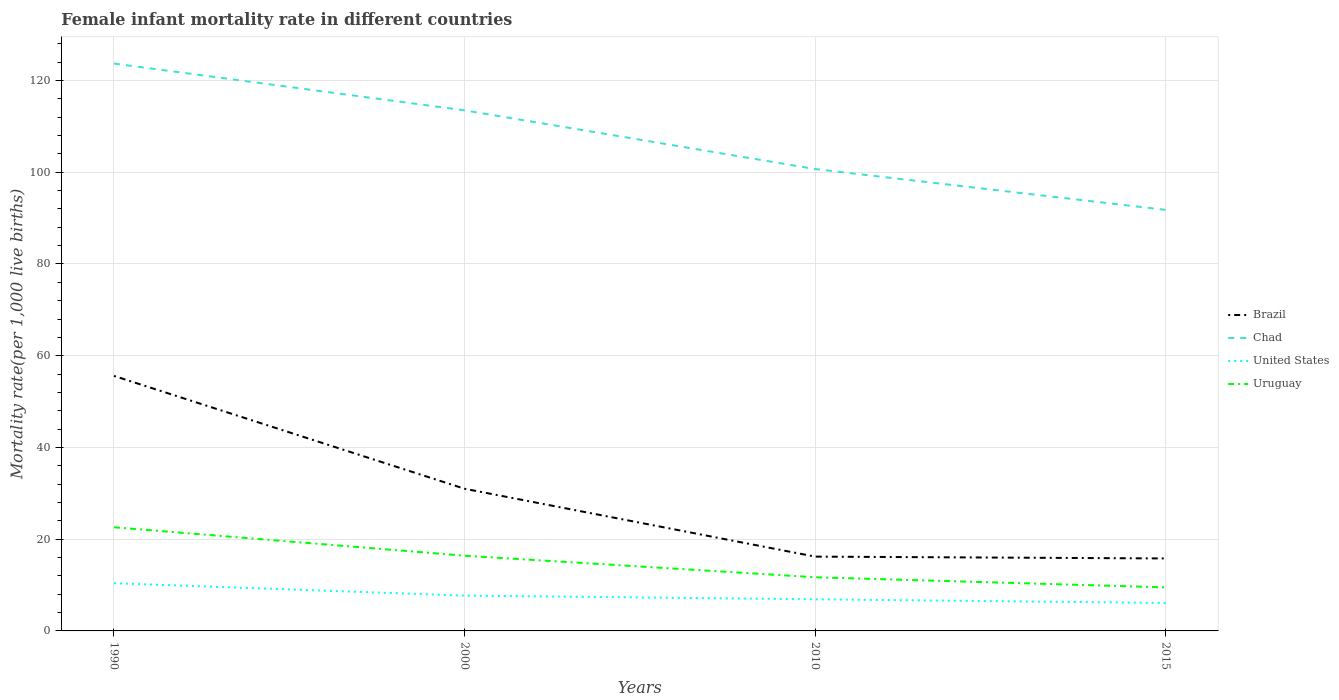In which year was the female infant mortality rate in Chad maximum?
Offer a very short reply. 2015. What is the total female infant mortality rate in Brazil in the graph?
Your response must be concise. 15.2. What is the difference between the highest and the second highest female infant mortality rate in United States?
Provide a short and direct response. 4.3. Is the female infant mortality rate in United States strictly greater than the female infant mortality rate in Uruguay over the years?
Ensure brevity in your answer.  Yes. How many years are there in the graph?
Make the answer very short. 4. What is the difference between two consecutive major ticks on the Y-axis?
Keep it short and to the point. 20. Does the graph contain grids?
Your answer should be very brief. Yes. Where does the legend appear in the graph?
Your response must be concise. Center right. How are the legend labels stacked?
Your response must be concise. Vertical. What is the title of the graph?
Your response must be concise. Female infant mortality rate in different countries. Does "Grenada" appear as one of the legend labels in the graph?
Give a very brief answer. No. What is the label or title of the Y-axis?
Your answer should be very brief. Mortality rate(per 1,0 live births). What is the Mortality rate(per 1,000 live births) of Brazil in 1990?
Your answer should be very brief. 55.6. What is the Mortality rate(per 1,000 live births) of Chad in 1990?
Offer a very short reply. 123.7. What is the Mortality rate(per 1,000 live births) of United States in 1990?
Make the answer very short. 10.4. What is the Mortality rate(per 1,000 live births) in Uruguay in 1990?
Provide a short and direct response. 22.6. What is the Mortality rate(per 1,000 live births) of Chad in 2000?
Your answer should be very brief. 113.5. What is the Mortality rate(per 1,000 live births) of Brazil in 2010?
Keep it short and to the point. 16.2. What is the Mortality rate(per 1,000 live births) of Chad in 2010?
Keep it short and to the point. 100.7. What is the Mortality rate(per 1,000 live births) of Uruguay in 2010?
Provide a succinct answer. 11.7. What is the Mortality rate(per 1,000 live births) of Chad in 2015?
Ensure brevity in your answer.  91.8. What is the Mortality rate(per 1,000 live births) in United States in 2015?
Your answer should be compact. 6.1. What is the Mortality rate(per 1,000 live births) in Uruguay in 2015?
Ensure brevity in your answer.  9.5. Across all years, what is the maximum Mortality rate(per 1,000 live births) of Brazil?
Provide a succinct answer. 55.6. Across all years, what is the maximum Mortality rate(per 1,000 live births) in Chad?
Keep it short and to the point. 123.7. Across all years, what is the maximum Mortality rate(per 1,000 live births) in Uruguay?
Make the answer very short. 22.6. Across all years, what is the minimum Mortality rate(per 1,000 live births) of Chad?
Offer a terse response. 91.8. What is the total Mortality rate(per 1,000 live births) in Brazil in the graph?
Your response must be concise. 118.6. What is the total Mortality rate(per 1,000 live births) in Chad in the graph?
Ensure brevity in your answer.  429.7. What is the total Mortality rate(per 1,000 live births) of United States in the graph?
Provide a short and direct response. 31.1. What is the total Mortality rate(per 1,000 live births) in Uruguay in the graph?
Give a very brief answer. 60.2. What is the difference between the Mortality rate(per 1,000 live births) of Brazil in 1990 and that in 2000?
Keep it short and to the point. 24.6. What is the difference between the Mortality rate(per 1,000 live births) in Chad in 1990 and that in 2000?
Provide a succinct answer. 10.2. What is the difference between the Mortality rate(per 1,000 live births) of Uruguay in 1990 and that in 2000?
Give a very brief answer. 6.2. What is the difference between the Mortality rate(per 1,000 live births) of Brazil in 1990 and that in 2010?
Provide a succinct answer. 39.4. What is the difference between the Mortality rate(per 1,000 live births) of Chad in 1990 and that in 2010?
Ensure brevity in your answer.  23. What is the difference between the Mortality rate(per 1,000 live births) in United States in 1990 and that in 2010?
Offer a terse response. 3.5. What is the difference between the Mortality rate(per 1,000 live births) in Uruguay in 1990 and that in 2010?
Offer a very short reply. 10.9. What is the difference between the Mortality rate(per 1,000 live births) of Brazil in 1990 and that in 2015?
Provide a short and direct response. 39.8. What is the difference between the Mortality rate(per 1,000 live births) of Chad in 1990 and that in 2015?
Your response must be concise. 31.9. What is the difference between the Mortality rate(per 1,000 live births) in United States in 1990 and that in 2015?
Your answer should be very brief. 4.3. What is the difference between the Mortality rate(per 1,000 live births) of Brazil in 2000 and that in 2010?
Your answer should be compact. 14.8. What is the difference between the Mortality rate(per 1,000 live births) of United States in 2000 and that in 2010?
Keep it short and to the point. 0.8. What is the difference between the Mortality rate(per 1,000 live births) in Uruguay in 2000 and that in 2010?
Your answer should be compact. 4.7. What is the difference between the Mortality rate(per 1,000 live births) in Brazil in 2000 and that in 2015?
Keep it short and to the point. 15.2. What is the difference between the Mortality rate(per 1,000 live births) of Chad in 2000 and that in 2015?
Make the answer very short. 21.7. What is the difference between the Mortality rate(per 1,000 live births) in United States in 2000 and that in 2015?
Offer a terse response. 1.6. What is the difference between the Mortality rate(per 1,000 live births) of Uruguay in 2000 and that in 2015?
Give a very brief answer. 6.9. What is the difference between the Mortality rate(per 1,000 live births) of Brazil in 2010 and that in 2015?
Your answer should be very brief. 0.4. What is the difference between the Mortality rate(per 1,000 live births) of Chad in 2010 and that in 2015?
Provide a short and direct response. 8.9. What is the difference between the Mortality rate(per 1,000 live births) in Uruguay in 2010 and that in 2015?
Provide a short and direct response. 2.2. What is the difference between the Mortality rate(per 1,000 live births) of Brazil in 1990 and the Mortality rate(per 1,000 live births) of Chad in 2000?
Ensure brevity in your answer.  -57.9. What is the difference between the Mortality rate(per 1,000 live births) of Brazil in 1990 and the Mortality rate(per 1,000 live births) of United States in 2000?
Your answer should be very brief. 47.9. What is the difference between the Mortality rate(per 1,000 live births) in Brazil in 1990 and the Mortality rate(per 1,000 live births) in Uruguay in 2000?
Provide a short and direct response. 39.2. What is the difference between the Mortality rate(per 1,000 live births) of Chad in 1990 and the Mortality rate(per 1,000 live births) of United States in 2000?
Make the answer very short. 116. What is the difference between the Mortality rate(per 1,000 live births) of Chad in 1990 and the Mortality rate(per 1,000 live births) of Uruguay in 2000?
Ensure brevity in your answer.  107.3. What is the difference between the Mortality rate(per 1,000 live births) in United States in 1990 and the Mortality rate(per 1,000 live births) in Uruguay in 2000?
Your response must be concise. -6. What is the difference between the Mortality rate(per 1,000 live births) in Brazil in 1990 and the Mortality rate(per 1,000 live births) in Chad in 2010?
Provide a short and direct response. -45.1. What is the difference between the Mortality rate(per 1,000 live births) in Brazil in 1990 and the Mortality rate(per 1,000 live births) in United States in 2010?
Make the answer very short. 48.7. What is the difference between the Mortality rate(per 1,000 live births) in Brazil in 1990 and the Mortality rate(per 1,000 live births) in Uruguay in 2010?
Ensure brevity in your answer.  43.9. What is the difference between the Mortality rate(per 1,000 live births) in Chad in 1990 and the Mortality rate(per 1,000 live births) in United States in 2010?
Your answer should be compact. 116.8. What is the difference between the Mortality rate(per 1,000 live births) of Chad in 1990 and the Mortality rate(per 1,000 live births) of Uruguay in 2010?
Ensure brevity in your answer.  112. What is the difference between the Mortality rate(per 1,000 live births) of United States in 1990 and the Mortality rate(per 1,000 live births) of Uruguay in 2010?
Ensure brevity in your answer.  -1.3. What is the difference between the Mortality rate(per 1,000 live births) of Brazil in 1990 and the Mortality rate(per 1,000 live births) of Chad in 2015?
Your response must be concise. -36.2. What is the difference between the Mortality rate(per 1,000 live births) of Brazil in 1990 and the Mortality rate(per 1,000 live births) of United States in 2015?
Your response must be concise. 49.5. What is the difference between the Mortality rate(per 1,000 live births) of Brazil in 1990 and the Mortality rate(per 1,000 live births) of Uruguay in 2015?
Ensure brevity in your answer.  46.1. What is the difference between the Mortality rate(per 1,000 live births) in Chad in 1990 and the Mortality rate(per 1,000 live births) in United States in 2015?
Keep it short and to the point. 117.6. What is the difference between the Mortality rate(per 1,000 live births) of Chad in 1990 and the Mortality rate(per 1,000 live births) of Uruguay in 2015?
Offer a terse response. 114.2. What is the difference between the Mortality rate(per 1,000 live births) in Brazil in 2000 and the Mortality rate(per 1,000 live births) in Chad in 2010?
Offer a very short reply. -69.7. What is the difference between the Mortality rate(per 1,000 live births) in Brazil in 2000 and the Mortality rate(per 1,000 live births) in United States in 2010?
Provide a short and direct response. 24.1. What is the difference between the Mortality rate(per 1,000 live births) in Brazil in 2000 and the Mortality rate(per 1,000 live births) in Uruguay in 2010?
Offer a terse response. 19.3. What is the difference between the Mortality rate(per 1,000 live births) of Chad in 2000 and the Mortality rate(per 1,000 live births) of United States in 2010?
Keep it short and to the point. 106.6. What is the difference between the Mortality rate(per 1,000 live births) of Chad in 2000 and the Mortality rate(per 1,000 live births) of Uruguay in 2010?
Your response must be concise. 101.8. What is the difference between the Mortality rate(per 1,000 live births) of United States in 2000 and the Mortality rate(per 1,000 live births) of Uruguay in 2010?
Your answer should be compact. -4. What is the difference between the Mortality rate(per 1,000 live births) of Brazil in 2000 and the Mortality rate(per 1,000 live births) of Chad in 2015?
Ensure brevity in your answer.  -60.8. What is the difference between the Mortality rate(per 1,000 live births) in Brazil in 2000 and the Mortality rate(per 1,000 live births) in United States in 2015?
Keep it short and to the point. 24.9. What is the difference between the Mortality rate(per 1,000 live births) in Chad in 2000 and the Mortality rate(per 1,000 live births) in United States in 2015?
Offer a very short reply. 107.4. What is the difference between the Mortality rate(per 1,000 live births) in Chad in 2000 and the Mortality rate(per 1,000 live births) in Uruguay in 2015?
Provide a succinct answer. 104. What is the difference between the Mortality rate(per 1,000 live births) of United States in 2000 and the Mortality rate(per 1,000 live births) of Uruguay in 2015?
Your answer should be compact. -1.8. What is the difference between the Mortality rate(per 1,000 live births) of Brazil in 2010 and the Mortality rate(per 1,000 live births) of Chad in 2015?
Offer a very short reply. -75.6. What is the difference between the Mortality rate(per 1,000 live births) in Brazil in 2010 and the Mortality rate(per 1,000 live births) in United States in 2015?
Your response must be concise. 10.1. What is the difference between the Mortality rate(per 1,000 live births) in Chad in 2010 and the Mortality rate(per 1,000 live births) in United States in 2015?
Offer a terse response. 94.6. What is the difference between the Mortality rate(per 1,000 live births) in Chad in 2010 and the Mortality rate(per 1,000 live births) in Uruguay in 2015?
Your answer should be very brief. 91.2. What is the difference between the Mortality rate(per 1,000 live births) in United States in 2010 and the Mortality rate(per 1,000 live births) in Uruguay in 2015?
Offer a terse response. -2.6. What is the average Mortality rate(per 1,000 live births) of Brazil per year?
Keep it short and to the point. 29.65. What is the average Mortality rate(per 1,000 live births) of Chad per year?
Keep it short and to the point. 107.42. What is the average Mortality rate(per 1,000 live births) in United States per year?
Ensure brevity in your answer.  7.78. What is the average Mortality rate(per 1,000 live births) of Uruguay per year?
Your response must be concise. 15.05. In the year 1990, what is the difference between the Mortality rate(per 1,000 live births) in Brazil and Mortality rate(per 1,000 live births) in Chad?
Keep it short and to the point. -68.1. In the year 1990, what is the difference between the Mortality rate(per 1,000 live births) in Brazil and Mortality rate(per 1,000 live births) in United States?
Keep it short and to the point. 45.2. In the year 1990, what is the difference between the Mortality rate(per 1,000 live births) of Chad and Mortality rate(per 1,000 live births) of United States?
Offer a terse response. 113.3. In the year 1990, what is the difference between the Mortality rate(per 1,000 live births) of Chad and Mortality rate(per 1,000 live births) of Uruguay?
Your answer should be very brief. 101.1. In the year 1990, what is the difference between the Mortality rate(per 1,000 live births) in United States and Mortality rate(per 1,000 live births) in Uruguay?
Offer a terse response. -12.2. In the year 2000, what is the difference between the Mortality rate(per 1,000 live births) in Brazil and Mortality rate(per 1,000 live births) in Chad?
Provide a succinct answer. -82.5. In the year 2000, what is the difference between the Mortality rate(per 1,000 live births) in Brazil and Mortality rate(per 1,000 live births) in United States?
Offer a very short reply. 23.3. In the year 2000, what is the difference between the Mortality rate(per 1,000 live births) of Chad and Mortality rate(per 1,000 live births) of United States?
Provide a short and direct response. 105.8. In the year 2000, what is the difference between the Mortality rate(per 1,000 live births) of Chad and Mortality rate(per 1,000 live births) of Uruguay?
Your response must be concise. 97.1. In the year 2010, what is the difference between the Mortality rate(per 1,000 live births) in Brazil and Mortality rate(per 1,000 live births) in Chad?
Your response must be concise. -84.5. In the year 2010, what is the difference between the Mortality rate(per 1,000 live births) of Chad and Mortality rate(per 1,000 live births) of United States?
Your answer should be compact. 93.8. In the year 2010, what is the difference between the Mortality rate(per 1,000 live births) in Chad and Mortality rate(per 1,000 live births) in Uruguay?
Keep it short and to the point. 89. In the year 2010, what is the difference between the Mortality rate(per 1,000 live births) of United States and Mortality rate(per 1,000 live births) of Uruguay?
Offer a terse response. -4.8. In the year 2015, what is the difference between the Mortality rate(per 1,000 live births) in Brazil and Mortality rate(per 1,000 live births) in Chad?
Provide a succinct answer. -76. In the year 2015, what is the difference between the Mortality rate(per 1,000 live births) of Brazil and Mortality rate(per 1,000 live births) of United States?
Make the answer very short. 9.7. In the year 2015, what is the difference between the Mortality rate(per 1,000 live births) in Chad and Mortality rate(per 1,000 live births) in United States?
Offer a very short reply. 85.7. In the year 2015, what is the difference between the Mortality rate(per 1,000 live births) of Chad and Mortality rate(per 1,000 live births) of Uruguay?
Offer a terse response. 82.3. What is the ratio of the Mortality rate(per 1,000 live births) of Brazil in 1990 to that in 2000?
Your answer should be very brief. 1.79. What is the ratio of the Mortality rate(per 1,000 live births) of Chad in 1990 to that in 2000?
Offer a very short reply. 1.09. What is the ratio of the Mortality rate(per 1,000 live births) in United States in 1990 to that in 2000?
Your answer should be compact. 1.35. What is the ratio of the Mortality rate(per 1,000 live births) in Uruguay in 1990 to that in 2000?
Offer a terse response. 1.38. What is the ratio of the Mortality rate(per 1,000 live births) of Brazil in 1990 to that in 2010?
Make the answer very short. 3.43. What is the ratio of the Mortality rate(per 1,000 live births) in Chad in 1990 to that in 2010?
Provide a short and direct response. 1.23. What is the ratio of the Mortality rate(per 1,000 live births) in United States in 1990 to that in 2010?
Keep it short and to the point. 1.51. What is the ratio of the Mortality rate(per 1,000 live births) of Uruguay in 1990 to that in 2010?
Offer a very short reply. 1.93. What is the ratio of the Mortality rate(per 1,000 live births) of Brazil in 1990 to that in 2015?
Offer a very short reply. 3.52. What is the ratio of the Mortality rate(per 1,000 live births) of Chad in 1990 to that in 2015?
Provide a succinct answer. 1.35. What is the ratio of the Mortality rate(per 1,000 live births) in United States in 1990 to that in 2015?
Ensure brevity in your answer.  1.7. What is the ratio of the Mortality rate(per 1,000 live births) in Uruguay in 1990 to that in 2015?
Your answer should be compact. 2.38. What is the ratio of the Mortality rate(per 1,000 live births) in Brazil in 2000 to that in 2010?
Your answer should be compact. 1.91. What is the ratio of the Mortality rate(per 1,000 live births) in Chad in 2000 to that in 2010?
Provide a succinct answer. 1.13. What is the ratio of the Mortality rate(per 1,000 live births) in United States in 2000 to that in 2010?
Your answer should be compact. 1.12. What is the ratio of the Mortality rate(per 1,000 live births) in Uruguay in 2000 to that in 2010?
Give a very brief answer. 1.4. What is the ratio of the Mortality rate(per 1,000 live births) of Brazil in 2000 to that in 2015?
Give a very brief answer. 1.96. What is the ratio of the Mortality rate(per 1,000 live births) in Chad in 2000 to that in 2015?
Provide a succinct answer. 1.24. What is the ratio of the Mortality rate(per 1,000 live births) of United States in 2000 to that in 2015?
Make the answer very short. 1.26. What is the ratio of the Mortality rate(per 1,000 live births) in Uruguay in 2000 to that in 2015?
Offer a very short reply. 1.73. What is the ratio of the Mortality rate(per 1,000 live births) of Brazil in 2010 to that in 2015?
Provide a succinct answer. 1.03. What is the ratio of the Mortality rate(per 1,000 live births) in Chad in 2010 to that in 2015?
Provide a short and direct response. 1.1. What is the ratio of the Mortality rate(per 1,000 live births) in United States in 2010 to that in 2015?
Keep it short and to the point. 1.13. What is the ratio of the Mortality rate(per 1,000 live births) of Uruguay in 2010 to that in 2015?
Offer a very short reply. 1.23. What is the difference between the highest and the second highest Mortality rate(per 1,000 live births) in Brazil?
Your answer should be compact. 24.6. What is the difference between the highest and the second highest Mortality rate(per 1,000 live births) in Uruguay?
Ensure brevity in your answer.  6.2. What is the difference between the highest and the lowest Mortality rate(per 1,000 live births) of Brazil?
Make the answer very short. 39.8. What is the difference between the highest and the lowest Mortality rate(per 1,000 live births) of Chad?
Offer a very short reply. 31.9. What is the difference between the highest and the lowest Mortality rate(per 1,000 live births) in Uruguay?
Provide a short and direct response. 13.1. 